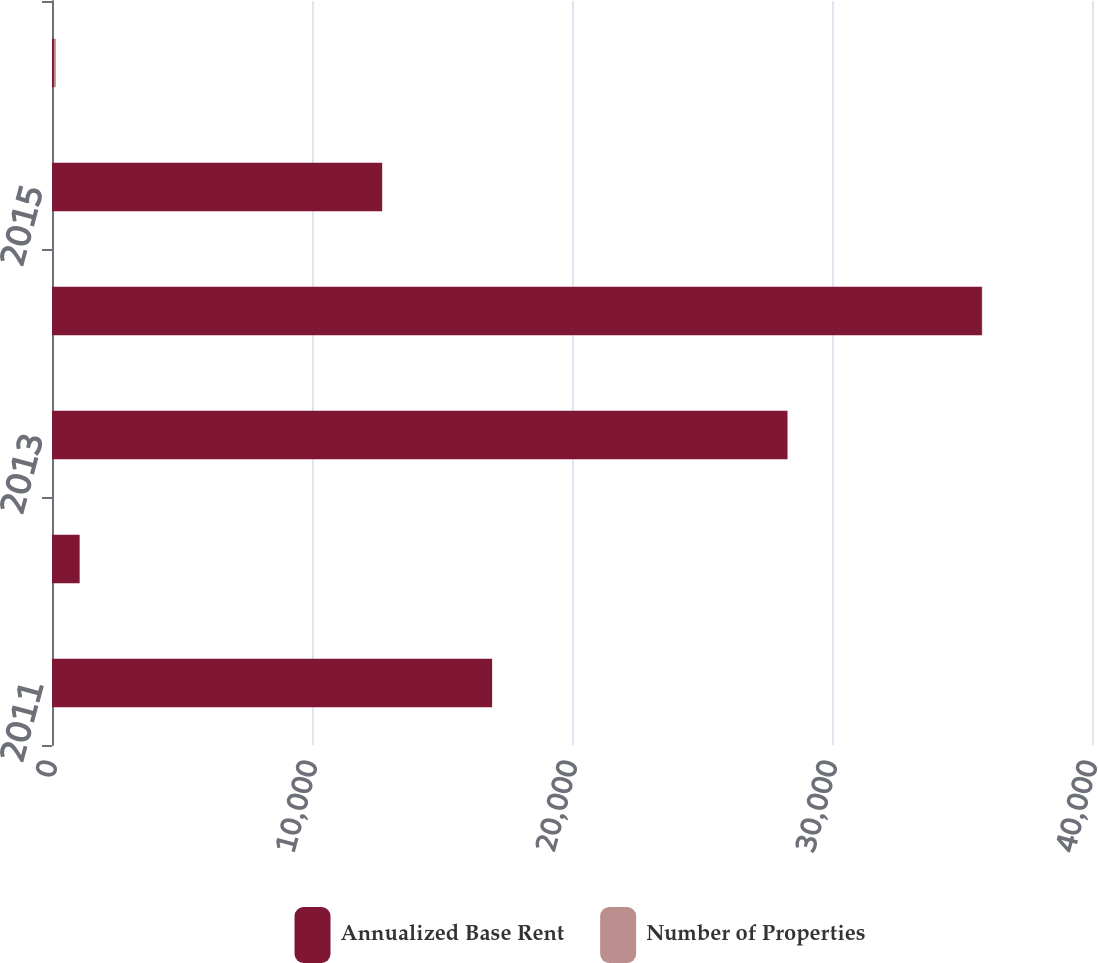Convert chart to OTSL. <chart><loc_0><loc_0><loc_500><loc_500><stacked_bar_chart><ecel><fcel>2011<fcel>2012<fcel>2013<fcel>2014<fcel>2015<fcel>Thereafter<nl><fcel>Annualized Base Rent<fcel>16923<fcel>1064<fcel>28289<fcel>35766<fcel>12694<fcel>74<nl><fcel>Number of Properties<fcel>10<fcel>2<fcel>13<fcel>15<fcel>12<fcel>74<nl></chart> 